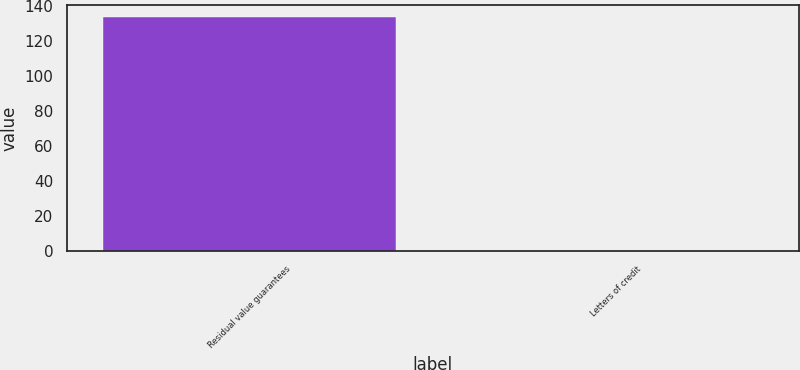Convert chart. <chart><loc_0><loc_0><loc_500><loc_500><bar_chart><fcel>Residual value guarantees<fcel>Letters of credit<nl><fcel>134<fcel>0.1<nl></chart> 